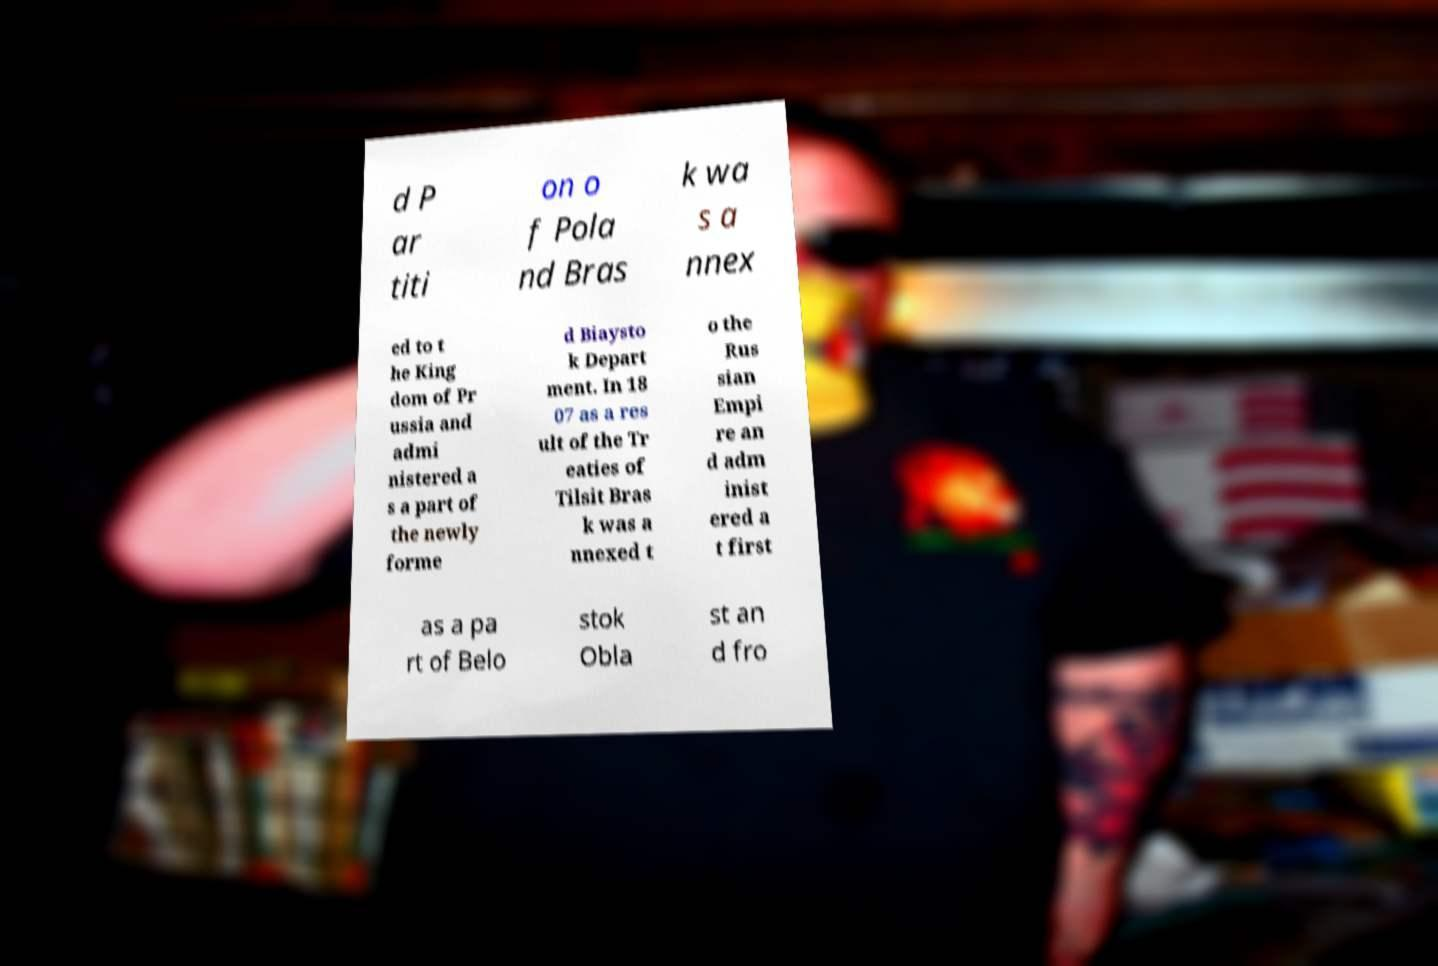Please read and relay the text visible in this image. What does it say? d P ar titi on o f Pola nd Bras k wa s a nnex ed to t he King dom of Pr ussia and admi nistered a s a part of the newly forme d Biaysto k Depart ment. In 18 07 as a res ult of the Tr eaties of Tilsit Bras k was a nnexed t o the Rus sian Empi re an d adm inist ered a t first as a pa rt of Belo stok Obla st an d fro 